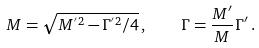<formula> <loc_0><loc_0><loc_500><loc_500>M = \sqrt { M ^ { ^ { \prime } 2 } - \Gamma ^ { ^ { \prime } 2 } / 4 } \, , \quad \Gamma = \frac { M ^ { \prime } } { M } \Gamma ^ { \prime } \, .</formula> 